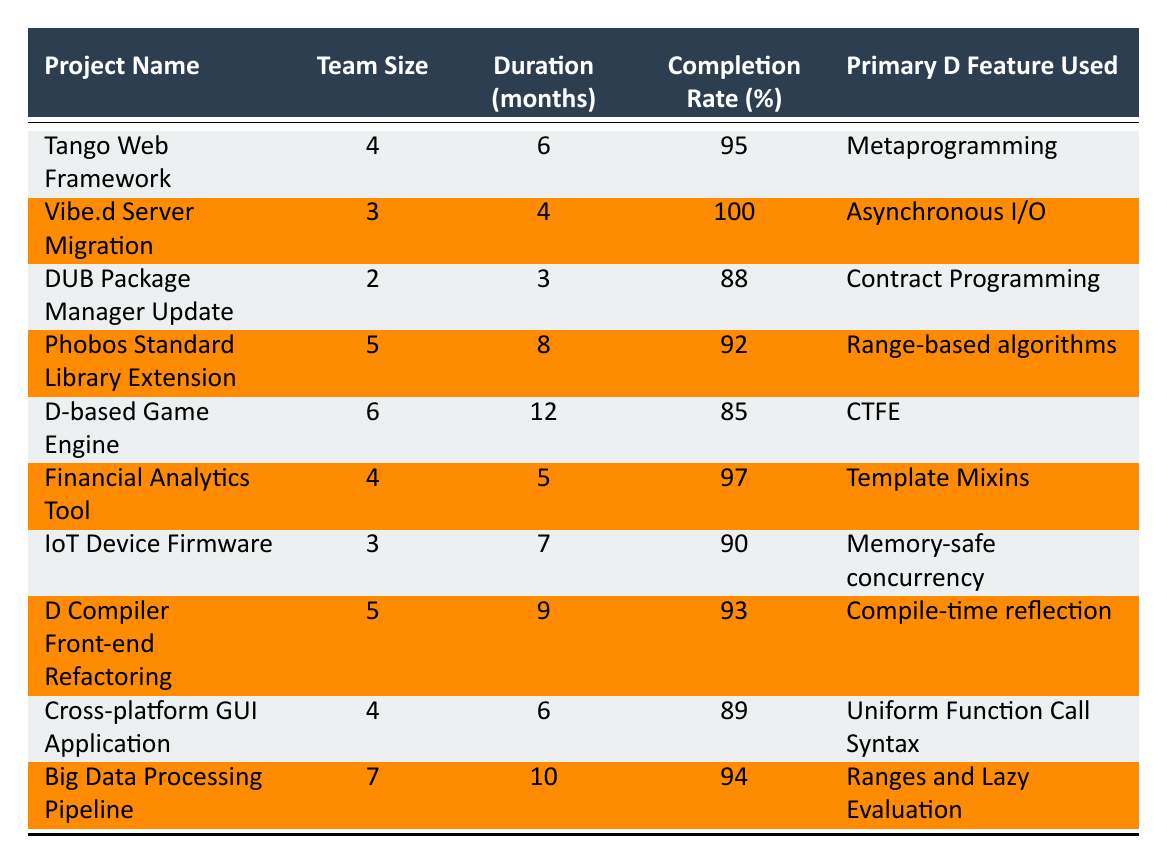What is the completion rate of the D-based Game Engine project? The completion rate is directly listed in the row for the D-based Game Engine project. Looking at that row, I see the value is 85%.
Answer: 85% How many months did it take to complete the Vibe.d Server Migration project? The duration for the Vibe.d Server Migration project is provided in the table, which states it took 4 months.
Answer: 4 months Which project has the highest completion rate? By reviewing the completion rates of all projects, I see that the Vibe.d Server Migration has a completion rate of 100%, which is the highest compared to others.
Answer: Vibe.d Server Migration What is the average completion rate for all the projects listed? To find the average, I will add all the completion rates: 95 + 100 + 88 + 92 + 85 + 97 + 90 + 93 + 89 + 94 = 919. There are 10 projects, so the average completion rate is 919 / 10 = 91.9%.
Answer: 91.9% Is there a project that used "CTFE" and has a completion rate over 90%? Looking at the table, the D-based Game Engine project used CTFE and has a completion rate of 85%, which does not meet the requirement of being over 90%. Therefore, the answer is no.
Answer: No How many projects had a team size of 4 or more members? I need to count the projects where the team size is 4 or above. The projects fitting this criterion are: Tango Web Framework, Phobos Standard Library Extension, Financial Analytics Tool, D Compiler Front-end Refactoring, Cross-platform GUI Application, and Big Data Processing Pipeline. That gives us a total of 6 projects.
Answer: 6 Which project took the longest to complete and what was its duration? The longest duration is found by scanning the durations listed. The D-based Game Engine took 12 months, which is the highest duration.
Answer: D-based Game Engine, 12 months Is the Financial Analytics Tool project completed in less time than the Phobos Standard Library Extension project? The duration for Financial Analytics Tool is 5 months, while for Phobos Standard Library Extension it is 8 months. Since 5 is less than 8, the answer is yes.
Answer: Yes 